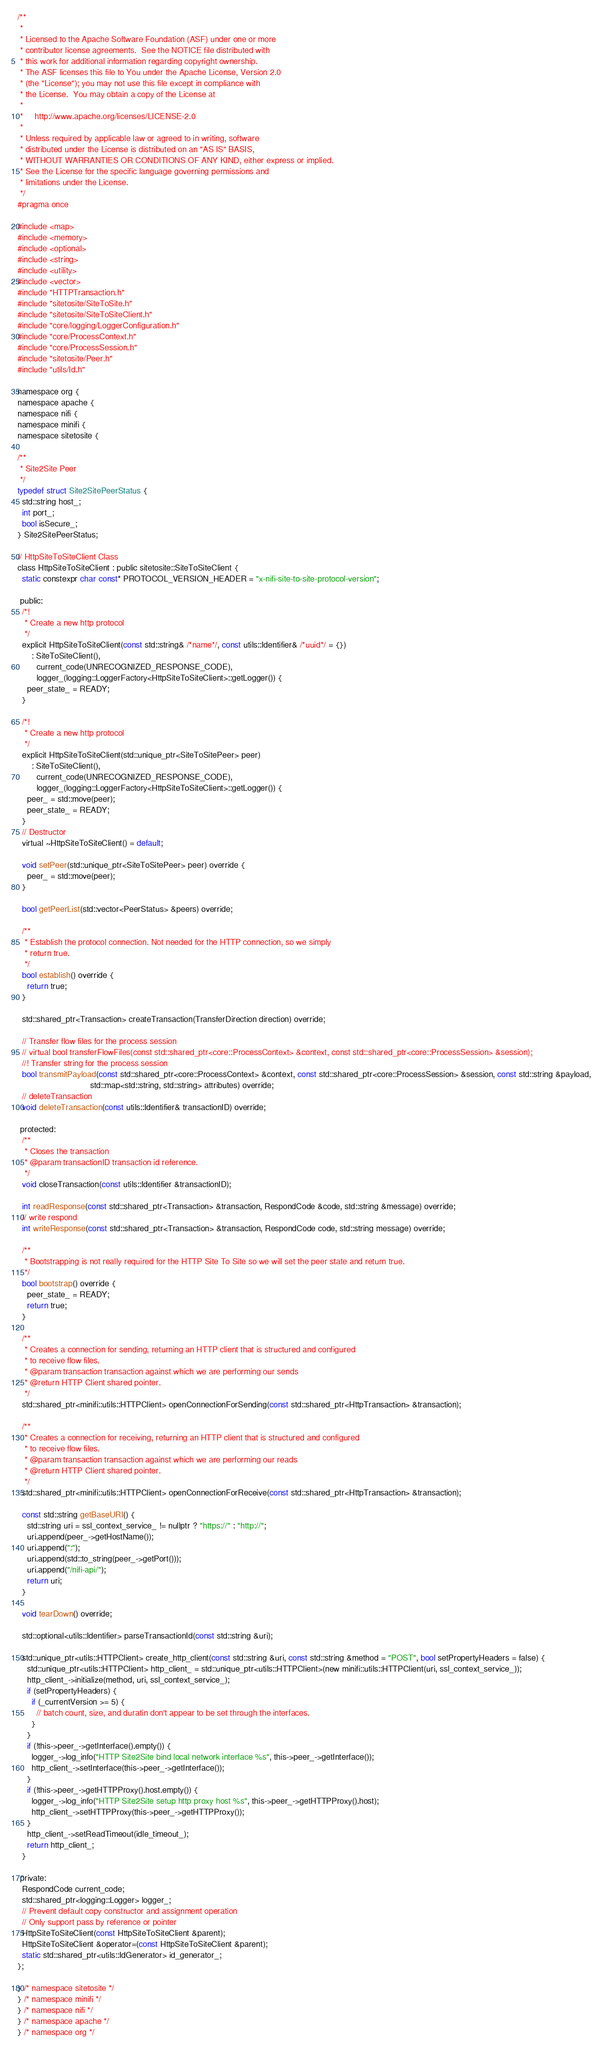Convert code to text. <code><loc_0><loc_0><loc_500><loc_500><_C_>/**
 *
 * Licensed to the Apache Software Foundation (ASF) under one or more
 * contributor license agreements.  See the NOTICE file distributed with
 * this work for additional information regarding copyright ownership.
 * The ASF licenses this file to You under the Apache License, Version 2.0
 * (the "License"); you may not use this file except in compliance with
 * the License.  You may obtain a copy of the License at
 *
 *     http://www.apache.org/licenses/LICENSE-2.0
 *
 * Unless required by applicable law or agreed to in writing, software
 * distributed under the License is distributed on an "AS IS" BASIS,
 * WITHOUT WARRANTIES OR CONDITIONS OF ANY KIND, either express or implied.
 * See the License for the specific language governing permissions and
 * limitations under the License.
 */
#pragma once

#include <map>
#include <memory>
#include <optional>
#include <string>
#include <utility>
#include <vector>
#include "HTTPTransaction.h"
#include "sitetosite/SiteToSite.h"
#include "sitetosite/SiteToSiteClient.h"
#include "core/logging/LoggerConfiguration.h"
#include "core/ProcessContext.h"
#include "core/ProcessSession.h"
#include "sitetosite/Peer.h"
#include "utils/Id.h"

namespace org {
namespace apache {
namespace nifi {
namespace minifi {
namespace sitetosite {

/**
 * Site2Site Peer
 */
typedef struct Site2SitePeerStatus {
  std::string host_;
  int port_;
  bool isSecure_;
} Site2SitePeerStatus;

// HttpSiteToSiteClient Class
class HttpSiteToSiteClient : public sitetosite::SiteToSiteClient {
  static constexpr char const* PROTOCOL_VERSION_HEADER = "x-nifi-site-to-site-protocol-version";

 public:
  /*!
   * Create a new http protocol
   */
  explicit HttpSiteToSiteClient(const std::string& /*name*/, const utils::Identifier& /*uuid*/ = {})
      : SiteToSiteClient(),
        current_code(UNRECOGNIZED_RESPONSE_CODE),
        logger_(logging::LoggerFactory<HttpSiteToSiteClient>::getLogger()) {
    peer_state_ = READY;
  }

  /*!
   * Create a new http protocol
   */
  explicit HttpSiteToSiteClient(std::unique_ptr<SiteToSitePeer> peer)
      : SiteToSiteClient(),
        current_code(UNRECOGNIZED_RESPONSE_CODE),
        logger_(logging::LoggerFactory<HttpSiteToSiteClient>::getLogger()) {
    peer_ = std::move(peer);
    peer_state_ = READY;
  }
  // Destructor
  virtual ~HttpSiteToSiteClient() = default;

  void setPeer(std::unique_ptr<SiteToSitePeer> peer) override {
    peer_ = std::move(peer);
  }

  bool getPeerList(std::vector<PeerStatus> &peers) override;

  /**
   * Establish the protocol connection. Not needed for the HTTP connection, so we simply
   * return true.
   */
  bool establish() override {
    return true;
  }

  std::shared_ptr<Transaction> createTransaction(TransferDirection direction) override;

  // Transfer flow files for the process session
  // virtual bool transferFlowFiles(const std::shared_ptr<core::ProcessContext> &context, const std::shared_ptr<core::ProcessSession> &session);
  //! Transfer string for the process session
  bool transmitPayload(const std::shared_ptr<core::ProcessContext> &context, const std::shared_ptr<core::ProcessSession> &session, const std::string &payload,
                               std::map<std::string, std::string> attributes) override;
  // deleteTransaction
  void deleteTransaction(const utils::Identifier& transactionID) override;

 protected:
  /**
   * Closes the transaction
   * @param transactionID transaction id reference.
   */
  void closeTransaction(const utils::Identifier &transactionID);

  int readResponse(const std::shared_ptr<Transaction> &transaction, RespondCode &code, std::string &message) override;
  // write respond
  int writeResponse(const std::shared_ptr<Transaction> &transaction, RespondCode code, std::string message) override;

  /**
   * Bootstrapping is not really required for the HTTP Site To Site so we will set the peer state and return true.
   */
  bool bootstrap() override {
    peer_state_ = READY;
    return true;
  }

  /**
   * Creates a connection for sending, returning an HTTP client that is structured and configured
   * to receive flow files.
   * @param transaction transaction against which we are performing our sends
   * @return HTTP Client shared pointer.
   */
  std::shared_ptr<minifi::utils::HTTPClient> openConnectionForSending(const std::shared_ptr<HttpTransaction> &transaction);

  /**
   * Creates a connection for receiving, returning an HTTP client that is structured and configured
   * to receive flow files.
   * @param transaction transaction against which we are performing our reads
   * @return HTTP Client shared pointer.
   */
  std::shared_ptr<minifi::utils::HTTPClient> openConnectionForReceive(const std::shared_ptr<HttpTransaction> &transaction);

  const std::string getBaseURI() {
    std::string uri = ssl_context_service_ != nullptr ? "https://" : "http://";
    uri.append(peer_->getHostName());
    uri.append(":");
    uri.append(std::to_string(peer_->getPort()));
    uri.append("/nifi-api/");
    return uri;
  }

  void tearDown() override;

  std::optional<utils::Identifier> parseTransactionId(const std::string &uri);

  std::unique_ptr<utils::HTTPClient> create_http_client(const std::string &uri, const std::string &method = "POST", bool setPropertyHeaders = false) {
    std::unique_ptr<utils::HTTPClient> http_client_ = std::unique_ptr<utils::HTTPClient>(new minifi::utils::HTTPClient(uri, ssl_context_service_));
    http_client_->initialize(method, uri, ssl_context_service_);
    if (setPropertyHeaders) {
      if (_currentVersion >= 5) {
        // batch count, size, and duratin don't appear to be set through the interfaces.
      }
    }
    if (!this->peer_->getInterface().empty()) {
      logger_->log_info("HTTP Site2Site bind local network interface %s", this->peer_->getInterface());
      http_client_->setInterface(this->peer_->getInterface());
    }
    if (!this->peer_->getHTTPProxy().host.empty()) {
      logger_->log_info("HTTP Site2Site setup http proxy host %s", this->peer_->getHTTPProxy().host);
      http_client_->setHTTPProxy(this->peer_->getHTTPProxy());
    }
    http_client_->setReadTimeout(idle_timeout_);
    return http_client_;
  }

 private:
  RespondCode current_code;
  std::shared_ptr<logging::Logger> logger_;
  // Prevent default copy constructor and assignment operation
  // Only support pass by reference or pointer
  HttpSiteToSiteClient(const HttpSiteToSiteClient &parent);
  HttpSiteToSiteClient &operator=(const HttpSiteToSiteClient &parent);
  static std::shared_ptr<utils::IdGenerator> id_generator_;
};

} /* namespace sitetosite */
} /* namespace minifi */
} /* namespace nifi */
} /* namespace apache */
} /* namespace org */
</code> 